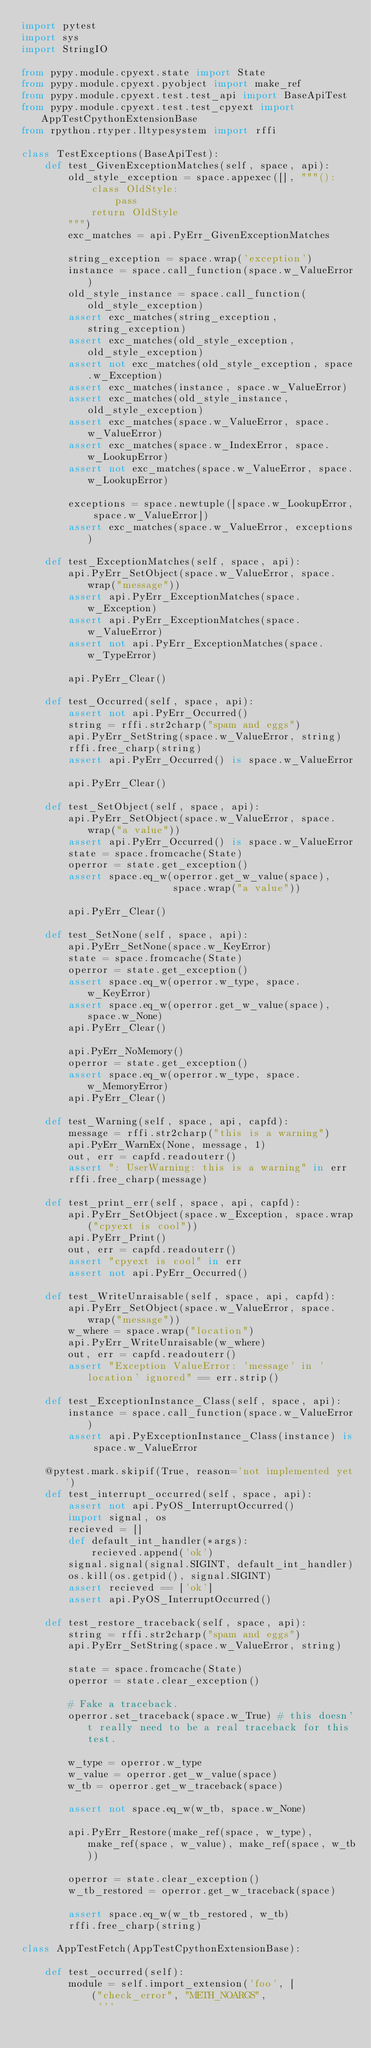<code> <loc_0><loc_0><loc_500><loc_500><_Python_>import pytest
import sys
import StringIO

from pypy.module.cpyext.state import State
from pypy.module.cpyext.pyobject import make_ref
from pypy.module.cpyext.test.test_api import BaseApiTest
from pypy.module.cpyext.test.test_cpyext import AppTestCpythonExtensionBase
from rpython.rtyper.lltypesystem import rffi

class TestExceptions(BaseApiTest):
    def test_GivenExceptionMatches(self, space, api):
        old_style_exception = space.appexec([], """():
            class OldStyle:
                pass
            return OldStyle
        """)
        exc_matches = api.PyErr_GivenExceptionMatches

        string_exception = space.wrap('exception')
        instance = space.call_function(space.w_ValueError)
        old_style_instance = space.call_function(old_style_exception)
        assert exc_matches(string_exception, string_exception)
        assert exc_matches(old_style_exception, old_style_exception)
        assert not exc_matches(old_style_exception, space.w_Exception)
        assert exc_matches(instance, space.w_ValueError)
        assert exc_matches(old_style_instance, old_style_exception)
        assert exc_matches(space.w_ValueError, space.w_ValueError)
        assert exc_matches(space.w_IndexError, space.w_LookupError)
        assert not exc_matches(space.w_ValueError, space.w_LookupError)

        exceptions = space.newtuple([space.w_LookupError, space.w_ValueError])
        assert exc_matches(space.w_ValueError, exceptions)

    def test_ExceptionMatches(self, space, api):
        api.PyErr_SetObject(space.w_ValueError, space.wrap("message"))
        assert api.PyErr_ExceptionMatches(space.w_Exception)
        assert api.PyErr_ExceptionMatches(space.w_ValueError)
        assert not api.PyErr_ExceptionMatches(space.w_TypeError)

        api.PyErr_Clear()

    def test_Occurred(self, space, api):
        assert not api.PyErr_Occurred()
        string = rffi.str2charp("spam and eggs")
        api.PyErr_SetString(space.w_ValueError, string)
        rffi.free_charp(string)
        assert api.PyErr_Occurred() is space.w_ValueError

        api.PyErr_Clear()

    def test_SetObject(self, space, api):
        api.PyErr_SetObject(space.w_ValueError, space.wrap("a value"))
        assert api.PyErr_Occurred() is space.w_ValueError
        state = space.fromcache(State)
        operror = state.get_exception()
        assert space.eq_w(operror.get_w_value(space),
                          space.wrap("a value"))

        api.PyErr_Clear()

    def test_SetNone(self, space, api):
        api.PyErr_SetNone(space.w_KeyError)
        state = space.fromcache(State)
        operror = state.get_exception()
        assert space.eq_w(operror.w_type, space.w_KeyError)
        assert space.eq_w(operror.get_w_value(space), space.w_None)
        api.PyErr_Clear()

        api.PyErr_NoMemory()
        operror = state.get_exception()
        assert space.eq_w(operror.w_type, space.w_MemoryError)
        api.PyErr_Clear()

    def test_Warning(self, space, api, capfd):
        message = rffi.str2charp("this is a warning")
        api.PyErr_WarnEx(None, message, 1)
        out, err = capfd.readouterr()
        assert ": UserWarning: this is a warning" in err
        rffi.free_charp(message)

    def test_print_err(self, space, api, capfd):
        api.PyErr_SetObject(space.w_Exception, space.wrap("cpyext is cool"))
        api.PyErr_Print()
        out, err = capfd.readouterr()
        assert "cpyext is cool" in err
        assert not api.PyErr_Occurred()

    def test_WriteUnraisable(self, space, api, capfd):
        api.PyErr_SetObject(space.w_ValueError, space.wrap("message"))
        w_where = space.wrap("location")
        api.PyErr_WriteUnraisable(w_where)
        out, err = capfd.readouterr()
        assert "Exception ValueError: 'message' in 'location' ignored" == err.strip()

    def test_ExceptionInstance_Class(self, space, api):
        instance = space.call_function(space.w_ValueError)
        assert api.PyExceptionInstance_Class(instance) is space.w_ValueError

    @pytest.mark.skipif(True, reason='not implemented yet')
    def test_interrupt_occurred(self, space, api):
        assert not api.PyOS_InterruptOccurred()
        import signal, os
        recieved = []
        def default_int_handler(*args):
            recieved.append('ok')
        signal.signal(signal.SIGINT, default_int_handler)
        os.kill(os.getpid(), signal.SIGINT)
        assert recieved == ['ok']
        assert api.PyOS_InterruptOccurred()

    def test_restore_traceback(self, space, api):
        string = rffi.str2charp("spam and eggs")
        api.PyErr_SetString(space.w_ValueError, string)

        state = space.fromcache(State)
        operror = state.clear_exception()

        # Fake a traceback.
        operror.set_traceback(space.w_True) # this doesn't really need to be a real traceback for this test.

        w_type = operror.w_type
        w_value = operror.get_w_value(space)
        w_tb = operror.get_w_traceback(space)

        assert not space.eq_w(w_tb, space.w_None)

        api.PyErr_Restore(make_ref(space, w_type), make_ref(space, w_value), make_ref(space, w_tb))

        operror = state.clear_exception()
        w_tb_restored = operror.get_w_traceback(space)

        assert space.eq_w(w_tb_restored, w_tb)
        rffi.free_charp(string)

class AppTestFetch(AppTestCpythonExtensionBase):

    def test_occurred(self):
        module = self.import_extension('foo', [
            ("check_error", "METH_NOARGS",
             '''</code> 